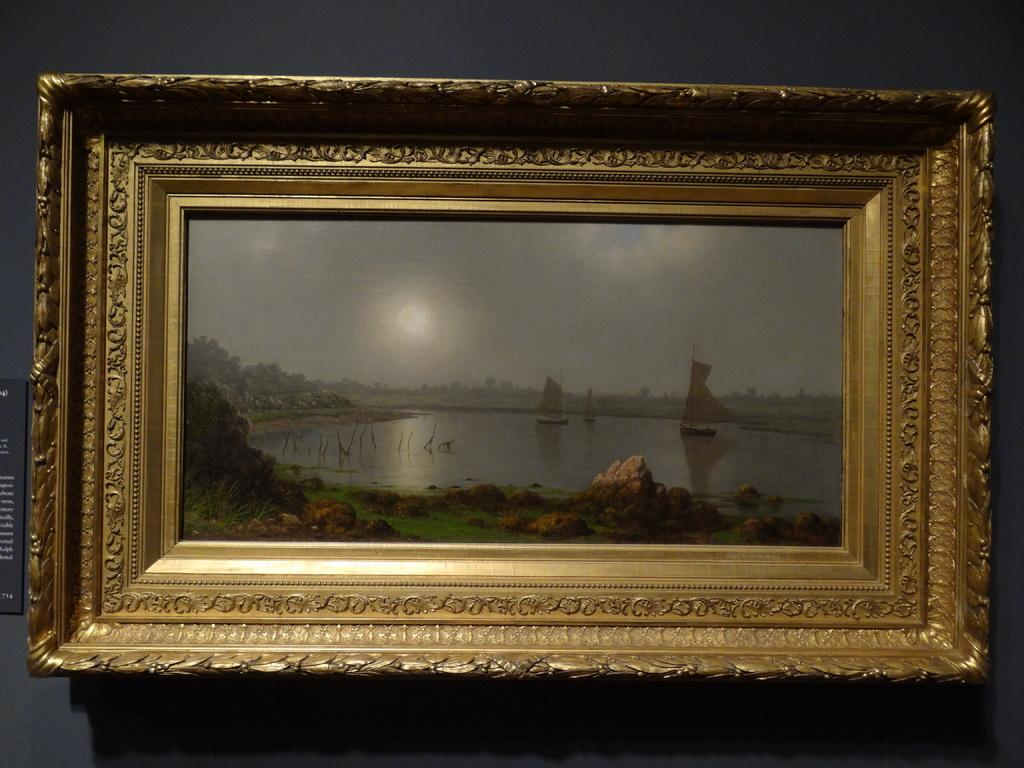What object in the picture contains a photo? There is a photo frame in the picture. What is shown in the photo inside the frame? The photo contains a lake. Are there any objects or vehicles in the lake? Yes, there is a boat in the lake. What type of vegetation can be seen in the picture? There are plants, grass, and trees in the picture. What is the condition of the sky in the picture? The sky is clear in the picture. What type of bun is being used in the picture? There is no bun present in the image. --- Facts: 1. There is a person in the image. 2. The person is wearing a hat. 3. The person is holding a book. 4. The book has a title on the cover. 5. The background of the image is a park. Absurd Topics: unicorn, piano Conversation: Who or what is present in the image? There is a person in the image. What is the person wearing in the image? The person is wearing a hat. What is the person holding in the image? The person is holding a book. What can be seen on the cover of the book? The book has a title on the cover. What is the background of the image? The background of the image is a park. Reasoning: Let's think step by step in order to produce the conversation. We start by identifying the main subject of the image, which is the person. Then, we describe the person's attire and what they are holding. Next, we mention the title on the cover of the book. Finally, we describe the background of the image, which is a park. Absurd Question/Answer: Can you see a unicorn playing the piano in the image? There is no unicorn or piano present in the image. --- Facts: 1. There is a group of people in the image. 2. The people are wearing matching t-shirts. 3. The t-shirts have a logo on the front. 4. The logo is a cartoon character. 5. The background of the image is a beach. Absurd Topics: rocket, surfboard, sandcastle Conversation: How many people are present in the image? There is a group of people in the image. What are the people wearing in the image? The people are wearing matching t-shirts. What can be seen on the front of the t-shirts? The t-shirts have a logo on the front. What type of logo is on the t-shirts? The logo is a cartoon character. What is the background of the image? The background of the image is a beach. Reasoning: 